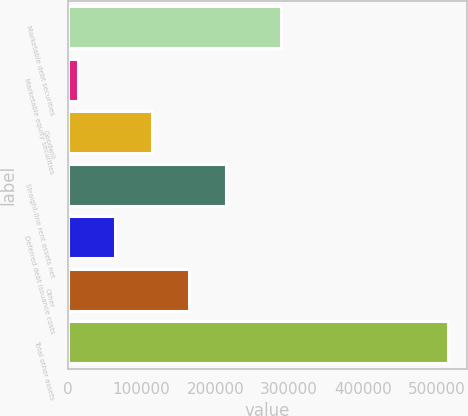<chart> <loc_0><loc_0><loc_500><loc_500><bar_chart><fcel>Marketable debt securities<fcel>Marketable equity securities<fcel>Goodwill<fcel>Straight-line rent assets net<fcel>Deferred debt issuance costs<fcel>Other<fcel>Total other assets<nl><fcel>289163<fcel>13761<fcel>114235<fcel>214710<fcel>63998.2<fcel>164473<fcel>516133<nl></chart> 